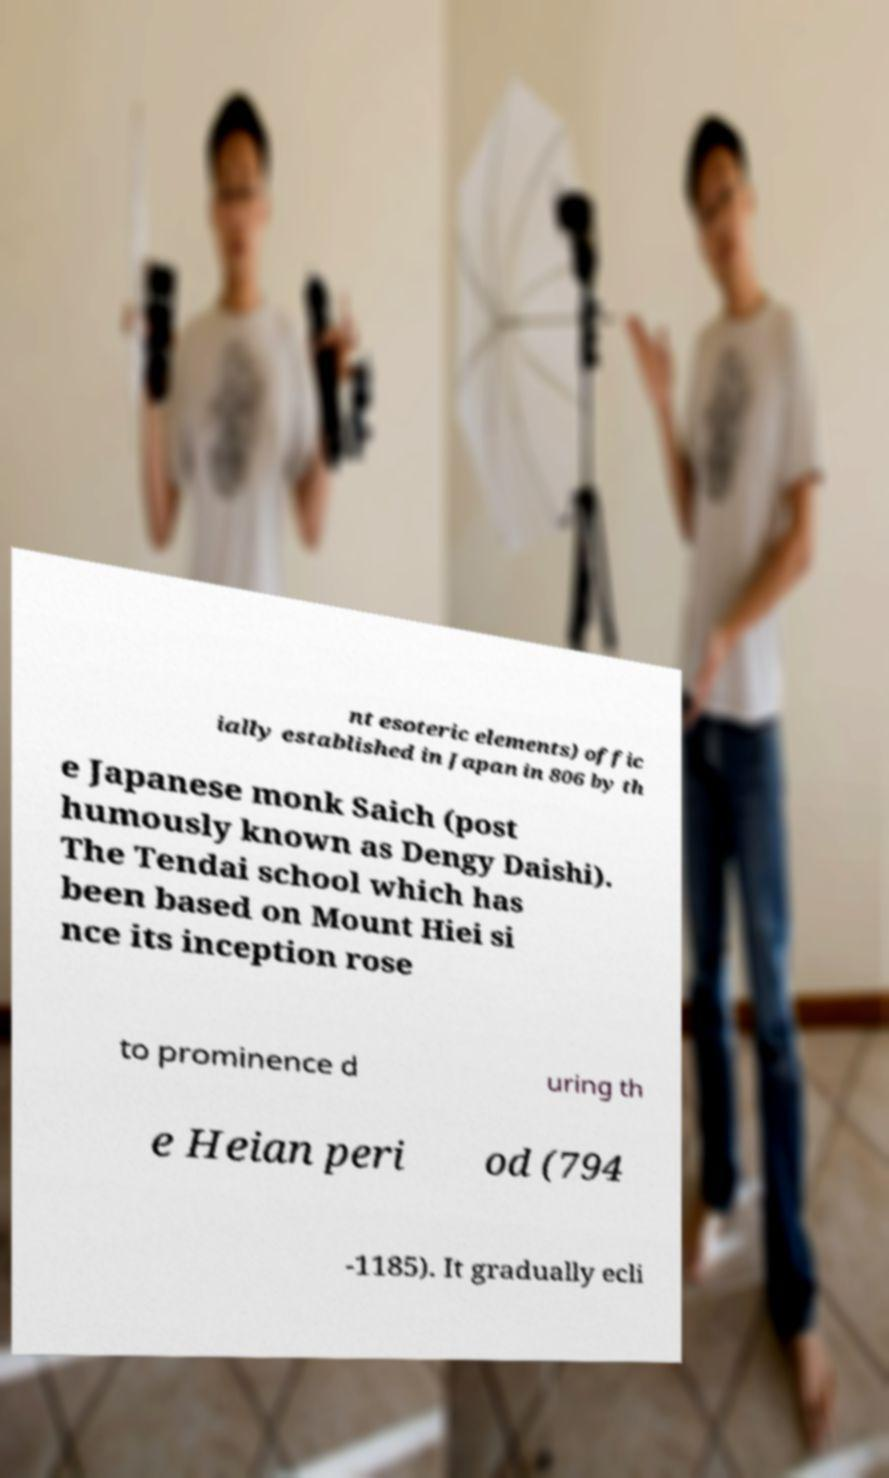Could you extract and type out the text from this image? nt esoteric elements) offic ially established in Japan in 806 by th e Japanese monk Saich (post humously known as Dengy Daishi). The Tendai school which has been based on Mount Hiei si nce its inception rose to prominence d uring th e Heian peri od (794 -1185). It gradually ecli 